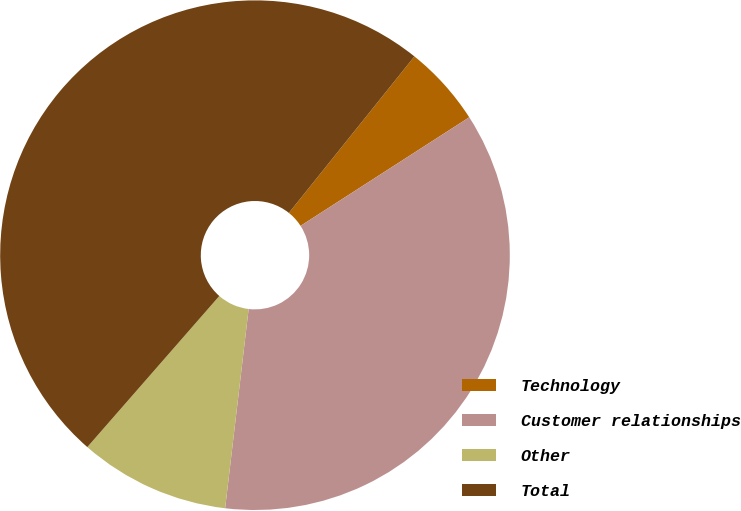<chart> <loc_0><loc_0><loc_500><loc_500><pie_chart><fcel>Technology<fcel>Customer relationships<fcel>Other<fcel>Total<nl><fcel>5.14%<fcel>35.97%<fcel>9.56%<fcel>49.33%<nl></chart> 